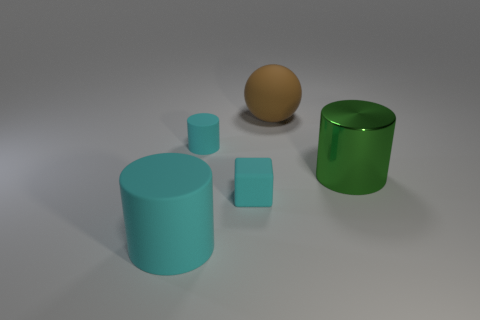Subtract all big cylinders. How many cylinders are left? 1 Add 2 small cylinders. How many objects exist? 7 Subtract all cubes. How many objects are left? 4 Subtract all matte things. Subtract all tiny yellow metallic cubes. How many objects are left? 1 Add 4 big green objects. How many big green objects are left? 5 Add 5 tiny red matte things. How many tiny red matte things exist? 5 Subtract 0 yellow cylinders. How many objects are left? 5 